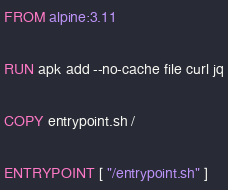<code> <loc_0><loc_0><loc_500><loc_500><_Dockerfile_>FROM alpine:3.11

RUN apk add --no-cache file curl jq

COPY entrypoint.sh /

ENTRYPOINT [ "/entrypoint.sh" ]
</code> 